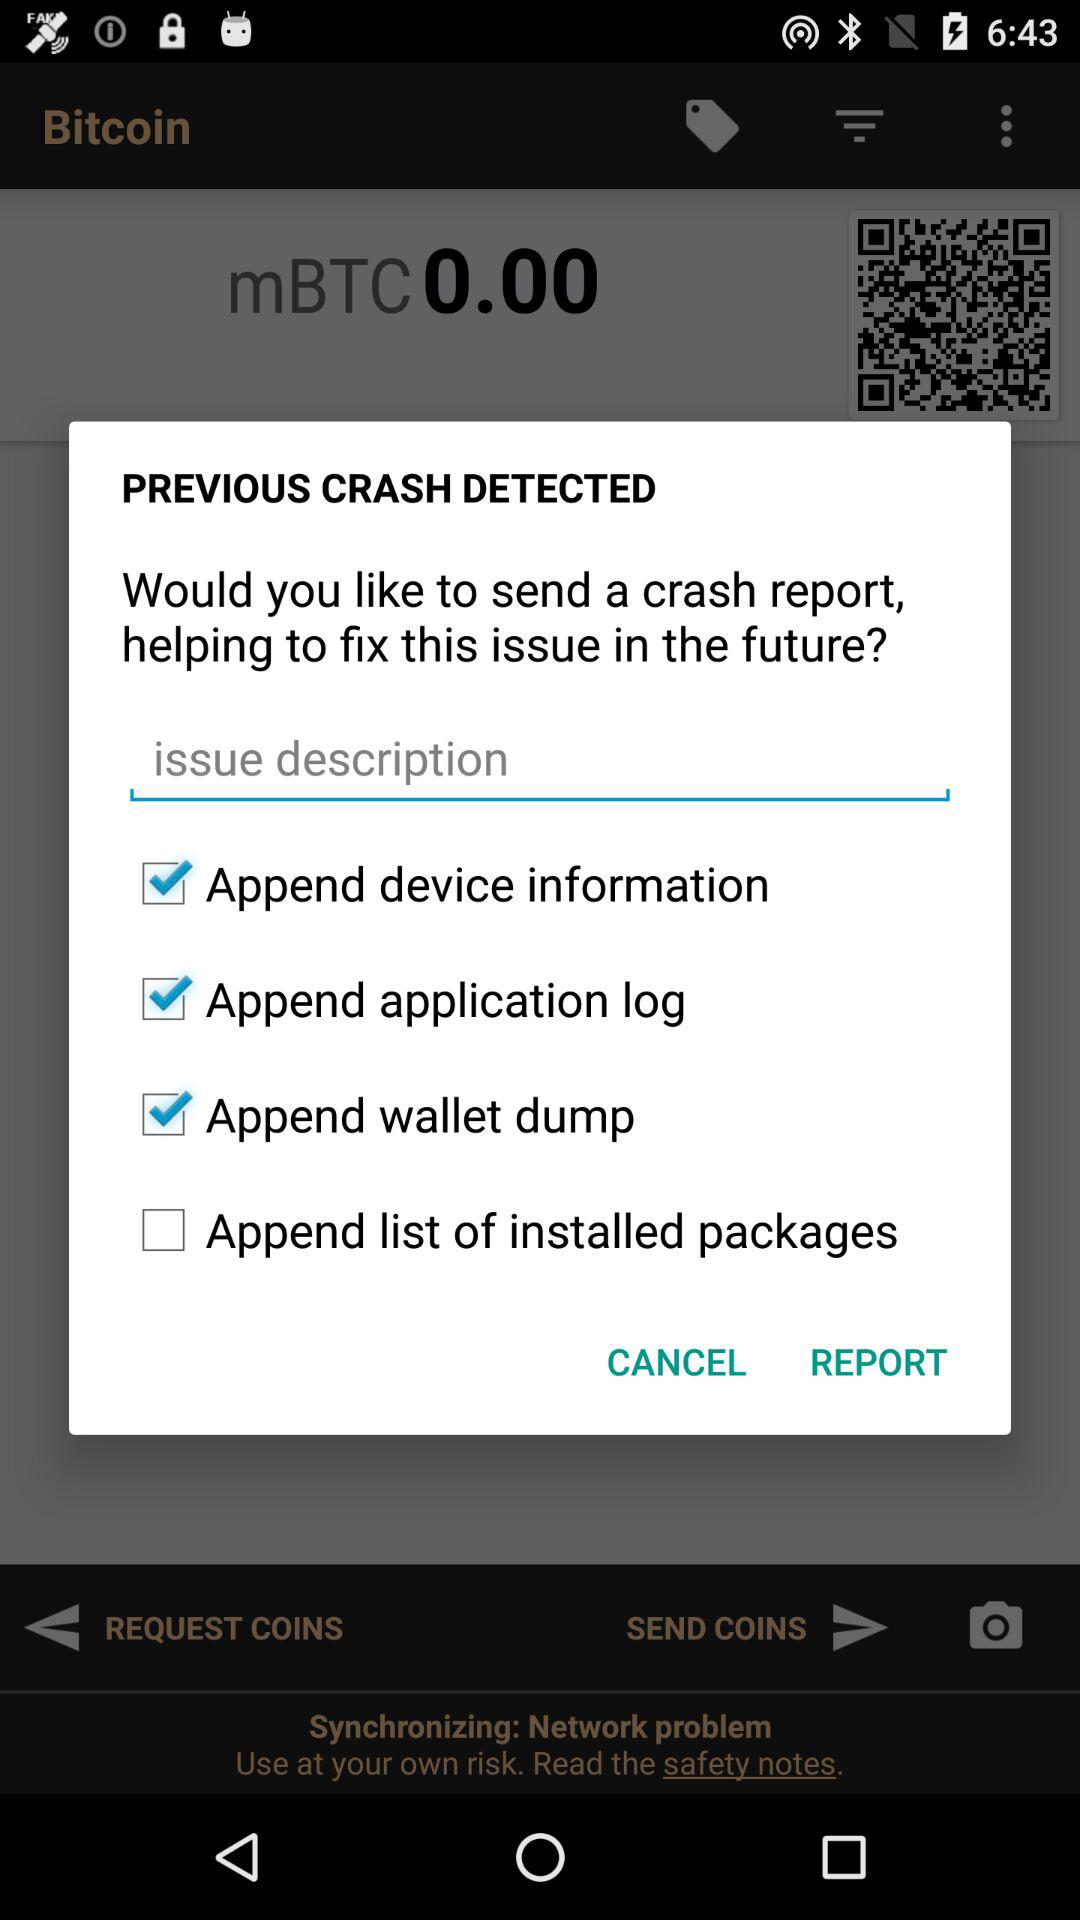What is the status of "Append device information"? The status is "on". 